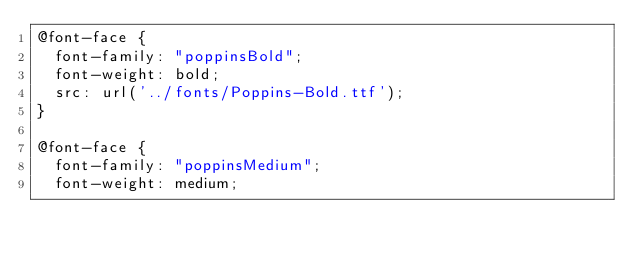<code> <loc_0><loc_0><loc_500><loc_500><_CSS_>@font-face {
  font-family: "poppinsBold";
  font-weight: bold;
  src: url('../fonts/Poppins-Bold.ttf');
}

@font-face {
  font-family: "poppinsMedium";
  font-weight: medium;</code> 